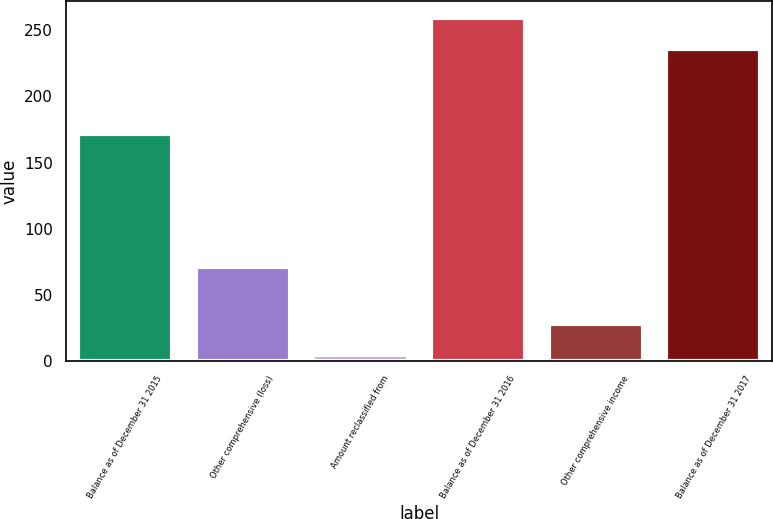Convert chart to OTSL. <chart><loc_0><loc_0><loc_500><loc_500><bar_chart><fcel>Balance as of December 31 2015<fcel>Other comprehensive (loss)<fcel>Amount reclassified from<fcel>Balance as of December 31 2016<fcel>Other comprehensive income<fcel>Balance as of December 31 2017<nl><fcel>171.7<fcel>70.7<fcel>4.4<fcel>259.06<fcel>27.76<fcel>235.7<nl></chart> 